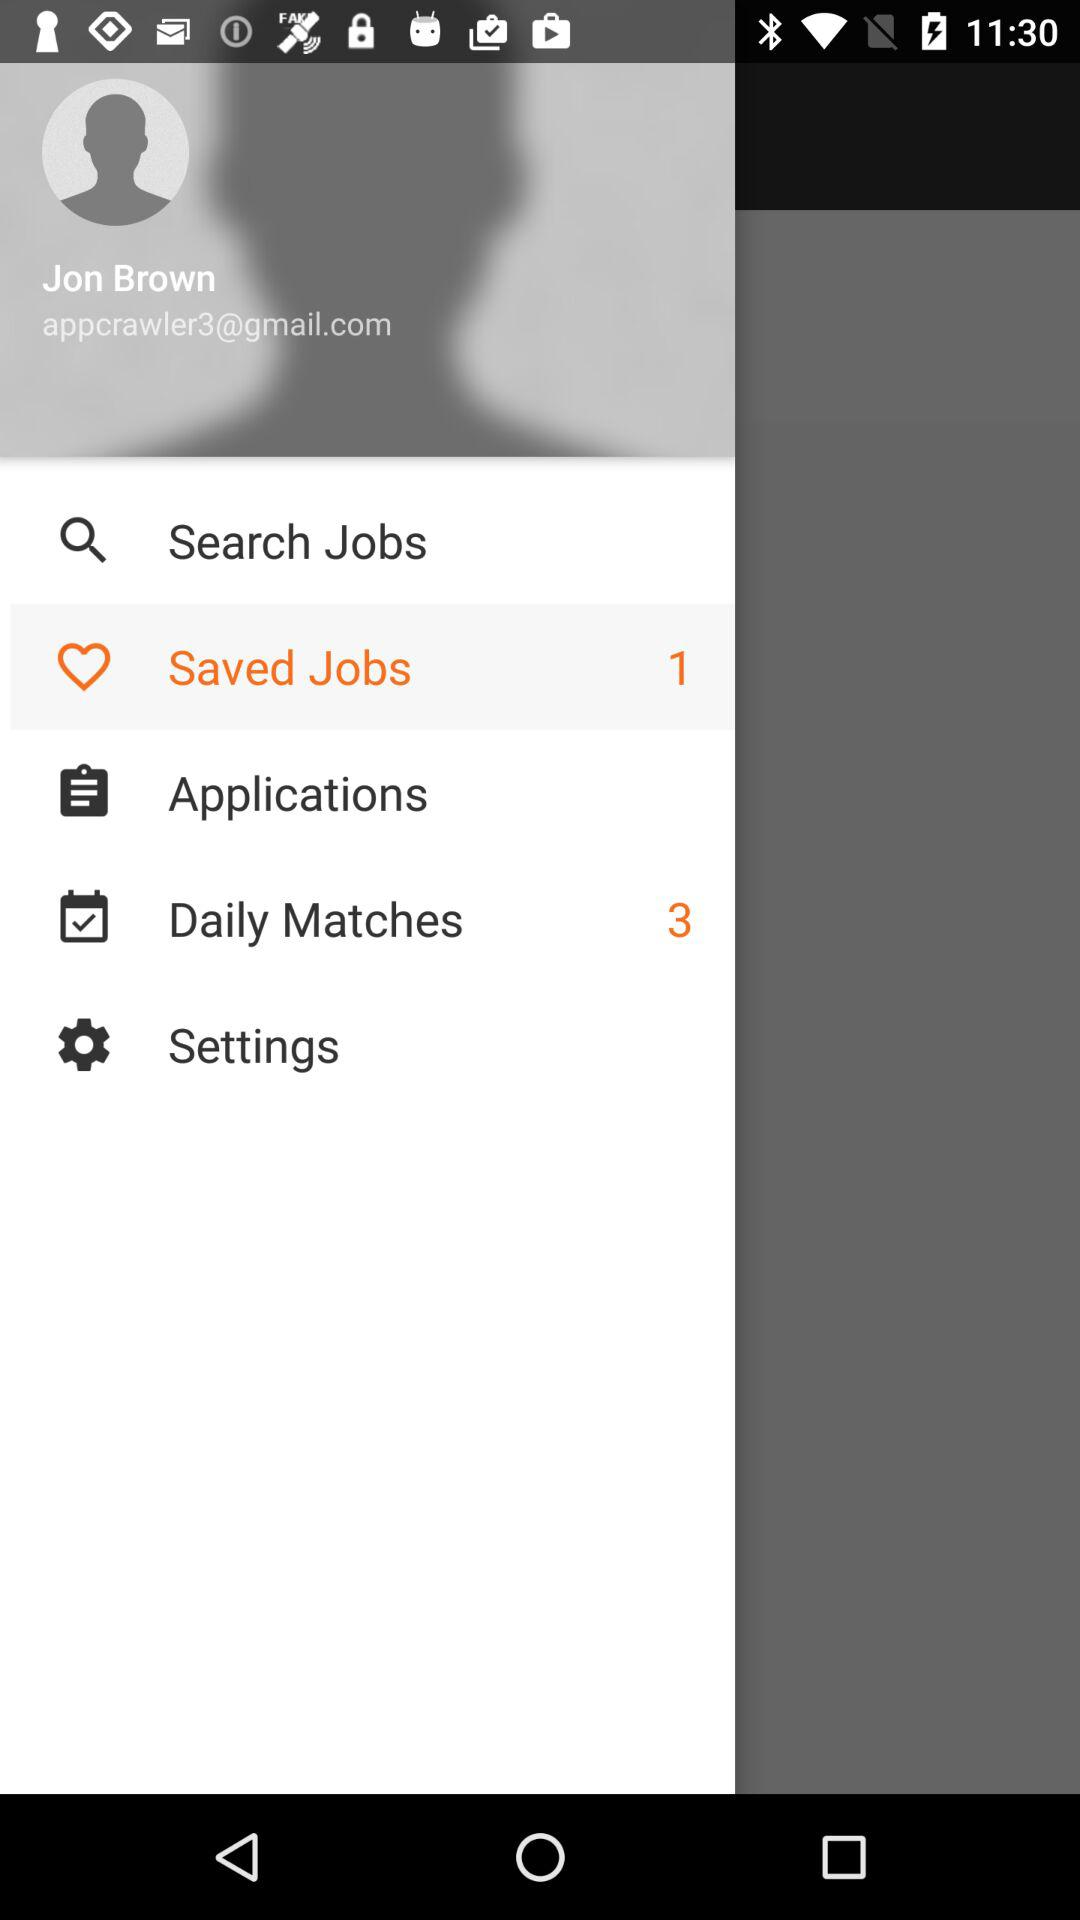How many saved jobs does Jon Brown have?
Answer the question using a single word or phrase. 1 